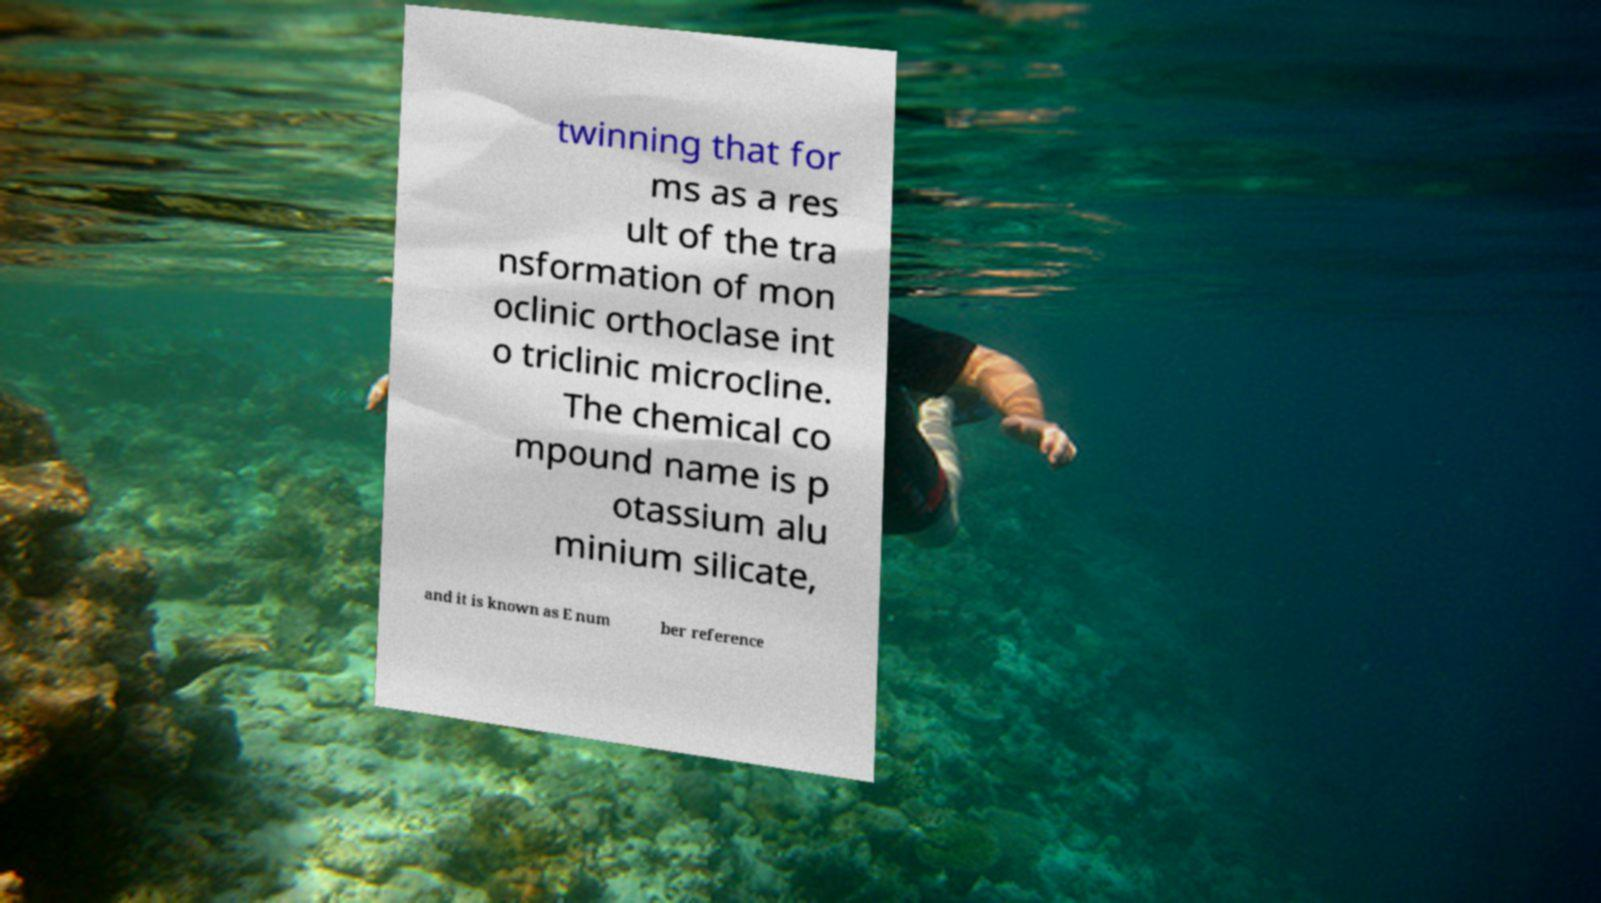Can you read and provide the text displayed in the image?This photo seems to have some interesting text. Can you extract and type it out for me? twinning that for ms as a res ult of the tra nsformation of mon oclinic orthoclase int o triclinic microcline. The chemical co mpound name is p otassium alu minium silicate, and it is known as E num ber reference 